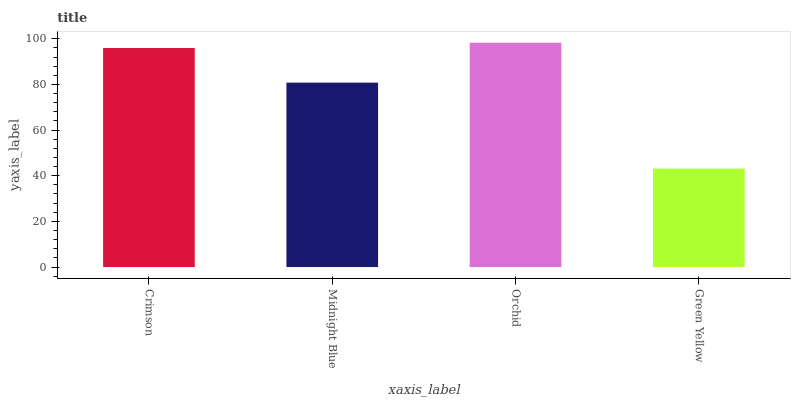Is Green Yellow the minimum?
Answer yes or no. Yes. Is Orchid the maximum?
Answer yes or no. Yes. Is Midnight Blue the minimum?
Answer yes or no. No. Is Midnight Blue the maximum?
Answer yes or no. No. Is Crimson greater than Midnight Blue?
Answer yes or no. Yes. Is Midnight Blue less than Crimson?
Answer yes or no. Yes. Is Midnight Blue greater than Crimson?
Answer yes or no. No. Is Crimson less than Midnight Blue?
Answer yes or no. No. Is Crimson the high median?
Answer yes or no. Yes. Is Midnight Blue the low median?
Answer yes or no. Yes. Is Green Yellow the high median?
Answer yes or no. No. Is Orchid the low median?
Answer yes or no. No. 